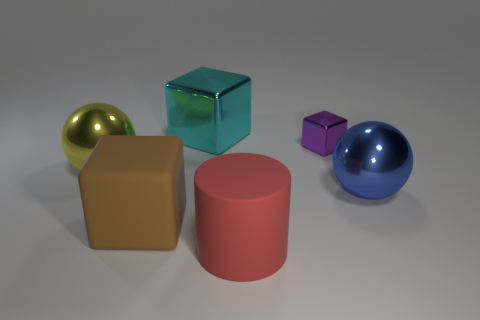Can you estimate the size ratio between the cube and the purple object? The purple object, which resembles a smaller cube, seems significantly smaller than the central turquoise cube. Judging by the image, the size ratio might be approximately 1 to 3 or 1 to 4, with the purple cube being the smaller. 